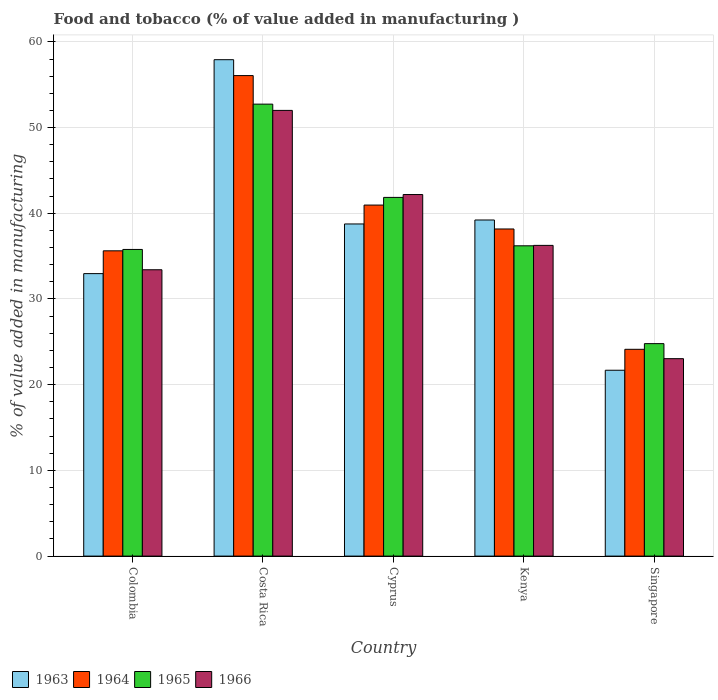How many groups of bars are there?
Your answer should be very brief. 5. Are the number of bars on each tick of the X-axis equal?
Your answer should be very brief. Yes. How many bars are there on the 4th tick from the left?
Keep it short and to the point. 4. How many bars are there on the 2nd tick from the right?
Offer a very short reply. 4. What is the label of the 3rd group of bars from the left?
Your answer should be compact. Cyprus. In how many cases, is the number of bars for a given country not equal to the number of legend labels?
Keep it short and to the point. 0. What is the value added in manufacturing food and tobacco in 1963 in Singapore?
Offer a very short reply. 21.69. Across all countries, what is the maximum value added in manufacturing food and tobacco in 1966?
Keep it short and to the point. 52. Across all countries, what is the minimum value added in manufacturing food and tobacco in 1963?
Make the answer very short. 21.69. In which country was the value added in manufacturing food and tobacco in 1963 minimum?
Keep it short and to the point. Singapore. What is the total value added in manufacturing food and tobacco in 1963 in the graph?
Provide a succinct answer. 190.54. What is the difference between the value added in manufacturing food and tobacco in 1963 in Colombia and that in Costa Rica?
Ensure brevity in your answer.  -24.96. What is the difference between the value added in manufacturing food and tobacco in 1966 in Costa Rica and the value added in manufacturing food and tobacco in 1963 in Colombia?
Make the answer very short. 19.04. What is the average value added in manufacturing food and tobacco in 1963 per country?
Provide a short and direct response. 38.11. What is the difference between the value added in manufacturing food and tobacco of/in 1966 and value added in manufacturing food and tobacco of/in 1963 in Singapore?
Give a very brief answer. 1.35. What is the ratio of the value added in manufacturing food and tobacco in 1963 in Colombia to that in Cyprus?
Your answer should be very brief. 0.85. Is the value added in manufacturing food and tobacco in 1964 in Cyprus less than that in Kenya?
Provide a succinct answer. No. What is the difference between the highest and the second highest value added in manufacturing food and tobacco in 1963?
Provide a short and direct response. 19.17. What is the difference between the highest and the lowest value added in manufacturing food and tobacco in 1963?
Provide a short and direct response. 36.23. In how many countries, is the value added in manufacturing food and tobacco in 1966 greater than the average value added in manufacturing food and tobacco in 1966 taken over all countries?
Ensure brevity in your answer.  2. Is the sum of the value added in manufacturing food and tobacco in 1965 in Cyprus and Kenya greater than the maximum value added in manufacturing food and tobacco in 1964 across all countries?
Make the answer very short. Yes. What does the 2nd bar from the left in Kenya represents?
Offer a terse response. 1964. What does the 2nd bar from the right in Colombia represents?
Ensure brevity in your answer.  1965. Where does the legend appear in the graph?
Make the answer very short. Bottom left. How many legend labels are there?
Your answer should be compact. 4. What is the title of the graph?
Ensure brevity in your answer.  Food and tobacco (% of value added in manufacturing ). What is the label or title of the X-axis?
Your answer should be compact. Country. What is the label or title of the Y-axis?
Provide a short and direct response. % of value added in manufacturing. What is the % of value added in manufacturing in 1963 in Colombia?
Your answer should be very brief. 32.96. What is the % of value added in manufacturing in 1964 in Colombia?
Your response must be concise. 35.62. What is the % of value added in manufacturing of 1965 in Colombia?
Provide a succinct answer. 35.78. What is the % of value added in manufacturing in 1966 in Colombia?
Your answer should be very brief. 33.41. What is the % of value added in manufacturing of 1963 in Costa Rica?
Your response must be concise. 57.92. What is the % of value added in manufacturing of 1964 in Costa Rica?
Keep it short and to the point. 56.07. What is the % of value added in manufacturing of 1965 in Costa Rica?
Your answer should be compact. 52.73. What is the % of value added in manufacturing in 1966 in Costa Rica?
Your response must be concise. 52. What is the % of value added in manufacturing of 1963 in Cyprus?
Make the answer very short. 38.75. What is the % of value added in manufacturing in 1964 in Cyprus?
Offer a terse response. 40.96. What is the % of value added in manufacturing in 1965 in Cyprus?
Your answer should be compact. 41.85. What is the % of value added in manufacturing in 1966 in Cyprus?
Offer a very short reply. 42.19. What is the % of value added in manufacturing of 1963 in Kenya?
Provide a short and direct response. 39.22. What is the % of value added in manufacturing in 1964 in Kenya?
Offer a terse response. 38.17. What is the % of value added in manufacturing in 1965 in Kenya?
Offer a very short reply. 36.2. What is the % of value added in manufacturing in 1966 in Kenya?
Your answer should be very brief. 36.25. What is the % of value added in manufacturing in 1963 in Singapore?
Your response must be concise. 21.69. What is the % of value added in manufacturing in 1964 in Singapore?
Offer a terse response. 24.13. What is the % of value added in manufacturing in 1965 in Singapore?
Offer a terse response. 24.79. What is the % of value added in manufacturing of 1966 in Singapore?
Offer a terse response. 23.04. Across all countries, what is the maximum % of value added in manufacturing of 1963?
Provide a short and direct response. 57.92. Across all countries, what is the maximum % of value added in manufacturing in 1964?
Your answer should be compact. 56.07. Across all countries, what is the maximum % of value added in manufacturing in 1965?
Offer a very short reply. 52.73. Across all countries, what is the maximum % of value added in manufacturing in 1966?
Ensure brevity in your answer.  52. Across all countries, what is the minimum % of value added in manufacturing in 1963?
Your answer should be very brief. 21.69. Across all countries, what is the minimum % of value added in manufacturing in 1964?
Offer a terse response. 24.13. Across all countries, what is the minimum % of value added in manufacturing of 1965?
Provide a succinct answer. 24.79. Across all countries, what is the minimum % of value added in manufacturing in 1966?
Ensure brevity in your answer.  23.04. What is the total % of value added in manufacturing in 1963 in the graph?
Make the answer very short. 190.54. What is the total % of value added in manufacturing of 1964 in the graph?
Ensure brevity in your answer.  194.94. What is the total % of value added in manufacturing of 1965 in the graph?
Your answer should be compact. 191.36. What is the total % of value added in manufacturing of 1966 in the graph?
Offer a very short reply. 186.89. What is the difference between the % of value added in manufacturing of 1963 in Colombia and that in Costa Rica?
Keep it short and to the point. -24.96. What is the difference between the % of value added in manufacturing in 1964 in Colombia and that in Costa Rica?
Offer a terse response. -20.45. What is the difference between the % of value added in manufacturing of 1965 in Colombia and that in Costa Rica?
Offer a terse response. -16.95. What is the difference between the % of value added in manufacturing in 1966 in Colombia and that in Costa Rica?
Provide a succinct answer. -18.59. What is the difference between the % of value added in manufacturing in 1963 in Colombia and that in Cyprus?
Keep it short and to the point. -5.79. What is the difference between the % of value added in manufacturing of 1964 in Colombia and that in Cyprus?
Offer a very short reply. -5.34. What is the difference between the % of value added in manufacturing of 1965 in Colombia and that in Cyprus?
Give a very brief answer. -6.07. What is the difference between the % of value added in manufacturing in 1966 in Colombia and that in Cyprus?
Provide a succinct answer. -8.78. What is the difference between the % of value added in manufacturing of 1963 in Colombia and that in Kenya?
Keep it short and to the point. -6.26. What is the difference between the % of value added in manufacturing in 1964 in Colombia and that in Kenya?
Your answer should be very brief. -2.55. What is the difference between the % of value added in manufacturing of 1965 in Colombia and that in Kenya?
Ensure brevity in your answer.  -0.42. What is the difference between the % of value added in manufacturing in 1966 in Colombia and that in Kenya?
Give a very brief answer. -2.84. What is the difference between the % of value added in manufacturing of 1963 in Colombia and that in Singapore?
Your answer should be very brief. 11.27. What is the difference between the % of value added in manufacturing in 1964 in Colombia and that in Singapore?
Give a very brief answer. 11.49. What is the difference between the % of value added in manufacturing in 1965 in Colombia and that in Singapore?
Make the answer very short. 10.99. What is the difference between the % of value added in manufacturing of 1966 in Colombia and that in Singapore?
Your answer should be very brief. 10.37. What is the difference between the % of value added in manufacturing in 1963 in Costa Rica and that in Cyprus?
Your answer should be very brief. 19.17. What is the difference between the % of value added in manufacturing of 1964 in Costa Rica and that in Cyprus?
Your response must be concise. 15.11. What is the difference between the % of value added in manufacturing in 1965 in Costa Rica and that in Cyprus?
Your answer should be very brief. 10.88. What is the difference between the % of value added in manufacturing in 1966 in Costa Rica and that in Cyprus?
Your answer should be very brief. 9.82. What is the difference between the % of value added in manufacturing of 1963 in Costa Rica and that in Kenya?
Your response must be concise. 18.7. What is the difference between the % of value added in manufacturing of 1964 in Costa Rica and that in Kenya?
Give a very brief answer. 17.9. What is the difference between the % of value added in manufacturing in 1965 in Costa Rica and that in Kenya?
Ensure brevity in your answer.  16.53. What is the difference between the % of value added in manufacturing in 1966 in Costa Rica and that in Kenya?
Provide a short and direct response. 15.75. What is the difference between the % of value added in manufacturing in 1963 in Costa Rica and that in Singapore?
Give a very brief answer. 36.23. What is the difference between the % of value added in manufacturing of 1964 in Costa Rica and that in Singapore?
Give a very brief answer. 31.94. What is the difference between the % of value added in manufacturing of 1965 in Costa Rica and that in Singapore?
Make the answer very short. 27.94. What is the difference between the % of value added in manufacturing in 1966 in Costa Rica and that in Singapore?
Keep it short and to the point. 28.97. What is the difference between the % of value added in manufacturing of 1963 in Cyprus and that in Kenya?
Ensure brevity in your answer.  -0.46. What is the difference between the % of value added in manufacturing of 1964 in Cyprus and that in Kenya?
Your answer should be compact. 2.79. What is the difference between the % of value added in manufacturing of 1965 in Cyprus and that in Kenya?
Your response must be concise. 5.65. What is the difference between the % of value added in manufacturing in 1966 in Cyprus and that in Kenya?
Your response must be concise. 5.93. What is the difference between the % of value added in manufacturing in 1963 in Cyprus and that in Singapore?
Your answer should be very brief. 17.07. What is the difference between the % of value added in manufacturing of 1964 in Cyprus and that in Singapore?
Ensure brevity in your answer.  16.83. What is the difference between the % of value added in manufacturing of 1965 in Cyprus and that in Singapore?
Give a very brief answer. 17.06. What is the difference between the % of value added in manufacturing in 1966 in Cyprus and that in Singapore?
Ensure brevity in your answer.  19.15. What is the difference between the % of value added in manufacturing of 1963 in Kenya and that in Singapore?
Provide a short and direct response. 17.53. What is the difference between the % of value added in manufacturing of 1964 in Kenya and that in Singapore?
Your answer should be compact. 14.04. What is the difference between the % of value added in manufacturing of 1965 in Kenya and that in Singapore?
Provide a short and direct response. 11.41. What is the difference between the % of value added in manufacturing of 1966 in Kenya and that in Singapore?
Give a very brief answer. 13.22. What is the difference between the % of value added in manufacturing in 1963 in Colombia and the % of value added in manufacturing in 1964 in Costa Rica?
Ensure brevity in your answer.  -23.11. What is the difference between the % of value added in manufacturing in 1963 in Colombia and the % of value added in manufacturing in 1965 in Costa Rica?
Offer a terse response. -19.77. What is the difference between the % of value added in manufacturing in 1963 in Colombia and the % of value added in manufacturing in 1966 in Costa Rica?
Ensure brevity in your answer.  -19.04. What is the difference between the % of value added in manufacturing in 1964 in Colombia and the % of value added in manufacturing in 1965 in Costa Rica?
Your answer should be compact. -17.11. What is the difference between the % of value added in manufacturing of 1964 in Colombia and the % of value added in manufacturing of 1966 in Costa Rica?
Your answer should be very brief. -16.38. What is the difference between the % of value added in manufacturing of 1965 in Colombia and the % of value added in manufacturing of 1966 in Costa Rica?
Keep it short and to the point. -16.22. What is the difference between the % of value added in manufacturing of 1963 in Colombia and the % of value added in manufacturing of 1964 in Cyprus?
Your answer should be very brief. -8. What is the difference between the % of value added in manufacturing in 1963 in Colombia and the % of value added in manufacturing in 1965 in Cyprus?
Offer a very short reply. -8.89. What is the difference between the % of value added in manufacturing of 1963 in Colombia and the % of value added in manufacturing of 1966 in Cyprus?
Your response must be concise. -9.23. What is the difference between the % of value added in manufacturing in 1964 in Colombia and the % of value added in manufacturing in 1965 in Cyprus?
Give a very brief answer. -6.23. What is the difference between the % of value added in manufacturing in 1964 in Colombia and the % of value added in manufacturing in 1966 in Cyprus?
Your answer should be very brief. -6.57. What is the difference between the % of value added in manufacturing of 1965 in Colombia and the % of value added in manufacturing of 1966 in Cyprus?
Your answer should be very brief. -6.41. What is the difference between the % of value added in manufacturing of 1963 in Colombia and the % of value added in manufacturing of 1964 in Kenya?
Provide a short and direct response. -5.21. What is the difference between the % of value added in manufacturing of 1963 in Colombia and the % of value added in manufacturing of 1965 in Kenya?
Ensure brevity in your answer.  -3.24. What is the difference between the % of value added in manufacturing in 1963 in Colombia and the % of value added in manufacturing in 1966 in Kenya?
Provide a short and direct response. -3.29. What is the difference between the % of value added in manufacturing in 1964 in Colombia and the % of value added in manufacturing in 1965 in Kenya?
Provide a succinct answer. -0.58. What is the difference between the % of value added in manufacturing of 1964 in Colombia and the % of value added in manufacturing of 1966 in Kenya?
Offer a very short reply. -0.63. What is the difference between the % of value added in manufacturing in 1965 in Colombia and the % of value added in manufacturing in 1966 in Kenya?
Your response must be concise. -0.47. What is the difference between the % of value added in manufacturing in 1963 in Colombia and the % of value added in manufacturing in 1964 in Singapore?
Offer a very short reply. 8.83. What is the difference between the % of value added in manufacturing of 1963 in Colombia and the % of value added in manufacturing of 1965 in Singapore?
Offer a very short reply. 8.17. What is the difference between the % of value added in manufacturing in 1963 in Colombia and the % of value added in manufacturing in 1966 in Singapore?
Provide a short and direct response. 9.92. What is the difference between the % of value added in manufacturing in 1964 in Colombia and the % of value added in manufacturing in 1965 in Singapore?
Make the answer very short. 10.83. What is the difference between the % of value added in manufacturing of 1964 in Colombia and the % of value added in manufacturing of 1966 in Singapore?
Your answer should be very brief. 12.58. What is the difference between the % of value added in manufacturing of 1965 in Colombia and the % of value added in manufacturing of 1966 in Singapore?
Make the answer very short. 12.74. What is the difference between the % of value added in manufacturing of 1963 in Costa Rica and the % of value added in manufacturing of 1964 in Cyprus?
Keep it short and to the point. 16.96. What is the difference between the % of value added in manufacturing of 1963 in Costa Rica and the % of value added in manufacturing of 1965 in Cyprus?
Your response must be concise. 16.07. What is the difference between the % of value added in manufacturing of 1963 in Costa Rica and the % of value added in manufacturing of 1966 in Cyprus?
Make the answer very short. 15.73. What is the difference between the % of value added in manufacturing in 1964 in Costa Rica and the % of value added in manufacturing in 1965 in Cyprus?
Keep it short and to the point. 14.21. What is the difference between the % of value added in manufacturing in 1964 in Costa Rica and the % of value added in manufacturing in 1966 in Cyprus?
Make the answer very short. 13.88. What is the difference between the % of value added in manufacturing in 1965 in Costa Rica and the % of value added in manufacturing in 1966 in Cyprus?
Give a very brief answer. 10.55. What is the difference between the % of value added in manufacturing of 1963 in Costa Rica and the % of value added in manufacturing of 1964 in Kenya?
Your answer should be compact. 19.75. What is the difference between the % of value added in manufacturing in 1963 in Costa Rica and the % of value added in manufacturing in 1965 in Kenya?
Ensure brevity in your answer.  21.72. What is the difference between the % of value added in manufacturing of 1963 in Costa Rica and the % of value added in manufacturing of 1966 in Kenya?
Ensure brevity in your answer.  21.67. What is the difference between the % of value added in manufacturing in 1964 in Costa Rica and the % of value added in manufacturing in 1965 in Kenya?
Keep it short and to the point. 19.86. What is the difference between the % of value added in manufacturing in 1964 in Costa Rica and the % of value added in manufacturing in 1966 in Kenya?
Offer a very short reply. 19.81. What is the difference between the % of value added in manufacturing in 1965 in Costa Rica and the % of value added in manufacturing in 1966 in Kenya?
Provide a succinct answer. 16.48. What is the difference between the % of value added in manufacturing in 1963 in Costa Rica and the % of value added in manufacturing in 1964 in Singapore?
Provide a short and direct response. 33.79. What is the difference between the % of value added in manufacturing in 1963 in Costa Rica and the % of value added in manufacturing in 1965 in Singapore?
Make the answer very short. 33.13. What is the difference between the % of value added in manufacturing of 1963 in Costa Rica and the % of value added in manufacturing of 1966 in Singapore?
Provide a succinct answer. 34.88. What is the difference between the % of value added in manufacturing of 1964 in Costa Rica and the % of value added in manufacturing of 1965 in Singapore?
Offer a terse response. 31.28. What is the difference between the % of value added in manufacturing of 1964 in Costa Rica and the % of value added in manufacturing of 1966 in Singapore?
Ensure brevity in your answer.  33.03. What is the difference between the % of value added in manufacturing in 1965 in Costa Rica and the % of value added in manufacturing in 1966 in Singapore?
Offer a very short reply. 29.7. What is the difference between the % of value added in manufacturing of 1963 in Cyprus and the % of value added in manufacturing of 1964 in Kenya?
Your response must be concise. 0.59. What is the difference between the % of value added in manufacturing of 1963 in Cyprus and the % of value added in manufacturing of 1965 in Kenya?
Your answer should be very brief. 2.55. What is the difference between the % of value added in manufacturing of 1963 in Cyprus and the % of value added in manufacturing of 1966 in Kenya?
Your answer should be compact. 2.5. What is the difference between the % of value added in manufacturing in 1964 in Cyprus and the % of value added in manufacturing in 1965 in Kenya?
Offer a terse response. 4.75. What is the difference between the % of value added in manufacturing in 1964 in Cyprus and the % of value added in manufacturing in 1966 in Kenya?
Your response must be concise. 4.7. What is the difference between the % of value added in manufacturing of 1965 in Cyprus and the % of value added in manufacturing of 1966 in Kenya?
Offer a very short reply. 5.6. What is the difference between the % of value added in manufacturing of 1963 in Cyprus and the % of value added in manufacturing of 1964 in Singapore?
Make the answer very short. 14.63. What is the difference between the % of value added in manufacturing of 1963 in Cyprus and the % of value added in manufacturing of 1965 in Singapore?
Provide a short and direct response. 13.96. What is the difference between the % of value added in manufacturing of 1963 in Cyprus and the % of value added in manufacturing of 1966 in Singapore?
Make the answer very short. 15.72. What is the difference between the % of value added in manufacturing in 1964 in Cyprus and the % of value added in manufacturing in 1965 in Singapore?
Your response must be concise. 16.17. What is the difference between the % of value added in manufacturing of 1964 in Cyprus and the % of value added in manufacturing of 1966 in Singapore?
Provide a short and direct response. 17.92. What is the difference between the % of value added in manufacturing of 1965 in Cyprus and the % of value added in manufacturing of 1966 in Singapore?
Make the answer very short. 18.82. What is the difference between the % of value added in manufacturing in 1963 in Kenya and the % of value added in manufacturing in 1964 in Singapore?
Your answer should be compact. 15.09. What is the difference between the % of value added in manufacturing in 1963 in Kenya and the % of value added in manufacturing in 1965 in Singapore?
Your answer should be very brief. 14.43. What is the difference between the % of value added in manufacturing in 1963 in Kenya and the % of value added in manufacturing in 1966 in Singapore?
Keep it short and to the point. 16.18. What is the difference between the % of value added in manufacturing of 1964 in Kenya and the % of value added in manufacturing of 1965 in Singapore?
Your answer should be very brief. 13.38. What is the difference between the % of value added in manufacturing of 1964 in Kenya and the % of value added in manufacturing of 1966 in Singapore?
Provide a succinct answer. 15.13. What is the difference between the % of value added in manufacturing of 1965 in Kenya and the % of value added in manufacturing of 1966 in Singapore?
Your response must be concise. 13.17. What is the average % of value added in manufacturing of 1963 per country?
Provide a short and direct response. 38.11. What is the average % of value added in manufacturing in 1964 per country?
Your answer should be compact. 38.99. What is the average % of value added in manufacturing of 1965 per country?
Provide a succinct answer. 38.27. What is the average % of value added in manufacturing of 1966 per country?
Your answer should be very brief. 37.38. What is the difference between the % of value added in manufacturing of 1963 and % of value added in manufacturing of 1964 in Colombia?
Provide a succinct answer. -2.66. What is the difference between the % of value added in manufacturing of 1963 and % of value added in manufacturing of 1965 in Colombia?
Ensure brevity in your answer.  -2.82. What is the difference between the % of value added in manufacturing of 1963 and % of value added in manufacturing of 1966 in Colombia?
Your answer should be very brief. -0.45. What is the difference between the % of value added in manufacturing in 1964 and % of value added in manufacturing in 1965 in Colombia?
Make the answer very short. -0.16. What is the difference between the % of value added in manufacturing of 1964 and % of value added in manufacturing of 1966 in Colombia?
Offer a very short reply. 2.21. What is the difference between the % of value added in manufacturing in 1965 and % of value added in manufacturing in 1966 in Colombia?
Ensure brevity in your answer.  2.37. What is the difference between the % of value added in manufacturing in 1963 and % of value added in manufacturing in 1964 in Costa Rica?
Give a very brief answer. 1.85. What is the difference between the % of value added in manufacturing of 1963 and % of value added in manufacturing of 1965 in Costa Rica?
Provide a succinct answer. 5.19. What is the difference between the % of value added in manufacturing in 1963 and % of value added in manufacturing in 1966 in Costa Rica?
Provide a succinct answer. 5.92. What is the difference between the % of value added in manufacturing of 1964 and % of value added in manufacturing of 1965 in Costa Rica?
Your response must be concise. 3.33. What is the difference between the % of value added in manufacturing in 1964 and % of value added in manufacturing in 1966 in Costa Rica?
Your answer should be very brief. 4.06. What is the difference between the % of value added in manufacturing of 1965 and % of value added in manufacturing of 1966 in Costa Rica?
Your answer should be compact. 0.73. What is the difference between the % of value added in manufacturing in 1963 and % of value added in manufacturing in 1964 in Cyprus?
Your answer should be very brief. -2.2. What is the difference between the % of value added in manufacturing in 1963 and % of value added in manufacturing in 1965 in Cyprus?
Make the answer very short. -3.1. What is the difference between the % of value added in manufacturing in 1963 and % of value added in manufacturing in 1966 in Cyprus?
Offer a very short reply. -3.43. What is the difference between the % of value added in manufacturing of 1964 and % of value added in manufacturing of 1965 in Cyprus?
Your answer should be compact. -0.9. What is the difference between the % of value added in manufacturing of 1964 and % of value added in manufacturing of 1966 in Cyprus?
Give a very brief answer. -1.23. What is the difference between the % of value added in manufacturing of 1965 and % of value added in manufacturing of 1966 in Cyprus?
Give a very brief answer. -0.33. What is the difference between the % of value added in manufacturing in 1963 and % of value added in manufacturing in 1964 in Kenya?
Offer a terse response. 1.05. What is the difference between the % of value added in manufacturing of 1963 and % of value added in manufacturing of 1965 in Kenya?
Ensure brevity in your answer.  3.01. What is the difference between the % of value added in manufacturing in 1963 and % of value added in manufacturing in 1966 in Kenya?
Give a very brief answer. 2.96. What is the difference between the % of value added in manufacturing of 1964 and % of value added in manufacturing of 1965 in Kenya?
Your response must be concise. 1.96. What is the difference between the % of value added in manufacturing of 1964 and % of value added in manufacturing of 1966 in Kenya?
Ensure brevity in your answer.  1.91. What is the difference between the % of value added in manufacturing in 1963 and % of value added in manufacturing in 1964 in Singapore?
Your response must be concise. -2.44. What is the difference between the % of value added in manufacturing of 1963 and % of value added in manufacturing of 1965 in Singapore?
Make the answer very short. -3.1. What is the difference between the % of value added in manufacturing of 1963 and % of value added in manufacturing of 1966 in Singapore?
Your response must be concise. -1.35. What is the difference between the % of value added in manufacturing of 1964 and % of value added in manufacturing of 1965 in Singapore?
Your response must be concise. -0.66. What is the difference between the % of value added in manufacturing in 1964 and % of value added in manufacturing in 1966 in Singapore?
Offer a terse response. 1.09. What is the difference between the % of value added in manufacturing in 1965 and % of value added in manufacturing in 1966 in Singapore?
Your answer should be very brief. 1.75. What is the ratio of the % of value added in manufacturing in 1963 in Colombia to that in Costa Rica?
Your response must be concise. 0.57. What is the ratio of the % of value added in manufacturing of 1964 in Colombia to that in Costa Rica?
Provide a short and direct response. 0.64. What is the ratio of the % of value added in manufacturing in 1965 in Colombia to that in Costa Rica?
Your answer should be compact. 0.68. What is the ratio of the % of value added in manufacturing of 1966 in Colombia to that in Costa Rica?
Give a very brief answer. 0.64. What is the ratio of the % of value added in manufacturing of 1963 in Colombia to that in Cyprus?
Keep it short and to the point. 0.85. What is the ratio of the % of value added in manufacturing of 1964 in Colombia to that in Cyprus?
Make the answer very short. 0.87. What is the ratio of the % of value added in manufacturing of 1965 in Colombia to that in Cyprus?
Your answer should be very brief. 0.85. What is the ratio of the % of value added in manufacturing of 1966 in Colombia to that in Cyprus?
Make the answer very short. 0.79. What is the ratio of the % of value added in manufacturing in 1963 in Colombia to that in Kenya?
Provide a short and direct response. 0.84. What is the ratio of the % of value added in manufacturing of 1964 in Colombia to that in Kenya?
Your response must be concise. 0.93. What is the ratio of the % of value added in manufacturing in 1965 in Colombia to that in Kenya?
Keep it short and to the point. 0.99. What is the ratio of the % of value added in manufacturing of 1966 in Colombia to that in Kenya?
Offer a terse response. 0.92. What is the ratio of the % of value added in manufacturing of 1963 in Colombia to that in Singapore?
Offer a very short reply. 1.52. What is the ratio of the % of value added in manufacturing in 1964 in Colombia to that in Singapore?
Your response must be concise. 1.48. What is the ratio of the % of value added in manufacturing of 1965 in Colombia to that in Singapore?
Offer a very short reply. 1.44. What is the ratio of the % of value added in manufacturing in 1966 in Colombia to that in Singapore?
Provide a short and direct response. 1.45. What is the ratio of the % of value added in manufacturing in 1963 in Costa Rica to that in Cyprus?
Provide a succinct answer. 1.49. What is the ratio of the % of value added in manufacturing of 1964 in Costa Rica to that in Cyprus?
Give a very brief answer. 1.37. What is the ratio of the % of value added in manufacturing in 1965 in Costa Rica to that in Cyprus?
Your answer should be very brief. 1.26. What is the ratio of the % of value added in manufacturing in 1966 in Costa Rica to that in Cyprus?
Your answer should be compact. 1.23. What is the ratio of the % of value added in manufacturing of 1963 in Costa Rica to that in Kenya?
Make the answer very short. 1.48. What is the ratio of the % of value added in manufacturing in 1964 in Costa Rica to that in Kenya?
Offer a terse response. 1.47. What is the ratio of the % of value added in manufacturing of 1965 in Costa Rica to that in Kenya?
Make the answer very short. 1.46. What is the ratio of the % of value added in manufacturing in 1966 in Costa Rica to that in Kenya?
Keep it short and to the point. 1.43. What is the ratio of the % of value added in manufacturing in 1963 in Costa Rica to that in Singapore?
Your answer should be compact. 2.67. What is the ratio of the % of value added in manufacturing of 1964 in Costa Rica to that in Singapore?
Ensure brevity in your answer.  2.32. What is the ratio of the % of value added in manufacturing in 1965 in Costa Rica to that in Singapore?
Provide a succinct answer. 2.13. What is the ratio of the % of value added in manufacturing of 1966 in Costa Rica to that in Singapore?
Your response must be concise. 2.26. What is the ratio of the % of value added in manufacturing in 1963 in Cyprus to that in Kenya?
Provide a succinct answer. 0.99. What is the ratio of the % of value added in manufacturing of 1964 in Cyprus to that in Kenya?
Offer a very short reply. 1.07. What is the ratio of the % of value added in manufacturing in 1965 in Cyprus to that in Kenya?
Your answer should be compact. 1.16. What is the ratio of the % of value added in manufacturing of 1966 in Cyprus to that in Kenya?
Make the answer very short. 1.16. What is the ratio of the % of value added in manufacturing of 1963 in Cyprus to that in Singapore?
Your response must be concise. 1.79. What is the ratio of the % of value added in manufacturing of 1964 in Cyprus to that in Singapore?
Your response must be concise. 1.7. What is the ratio of the % of value added in manufacturing of 1965 in Cyprus to that in Singapore?
Your answer should be compact. 1.69. What is the ratio of the % of value added in manufacturing of 1966 in Cyprus to that in Singapore?
Ensure brevity in your answer.  1.83. What is the ratio of the % of value added in manufacturing of 1963 in Kenya to that in Singapore?
Ensure brevity in your answer.  1.81. What is the ratio of the % of value added in manufacturing in 1964 in Kenya to that in Singapore?
Your answer should be compact. 1.58. What is the ratio of the % of value added in manufacturing in 1965 in Kenya to that in Singapore?
Ensure brevity in your answer.  1.46. What is the ratio of the % of value added in manufacturing in 1966 in Kenya to that in Singapore?
Your response must be concise. 1.57. What is the difference between the highest and the second highest % of value added in manufacturing of 1963?
Ensure brevity in your answer.  18.7. What is the difference between the highest and the second highest % of value added in manufacturing in 1964?
Provide a succinct answer. 15.11. What is the difference between the highest and the second highest % of value added in manufacturing of 1965?
Your answer should be compact. 10.88. What is the difference between the highest and the second highest % of value added in manufacturing in 1966?
Give a very brief answer. 9.82. What is the difference between the highest and the lowest % of value added in manufacturing of 1963?
Make the answer very short. 36.23. What is the difference between the highest and the lowest % of value added in manufacturing in 1964?
Provide a short and direct response. 31.94. What is the difference between the highest and the lowest % of value added in manufacturing in 1965?
Your answer should be compact. 27.94. What is the difference between the highest and the lowest % of value added in manufacturing in 1966?
Your answer should be compact. 28.97. 